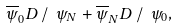<formula> <loc_0><loc_0><loc_500><loc_500>\overline { \psi } _ { 0 } D \, / \ \psi _ { N } + \overline { \psi } _ { N } D \, / \ \psi _ { 0 } ,</formula> 